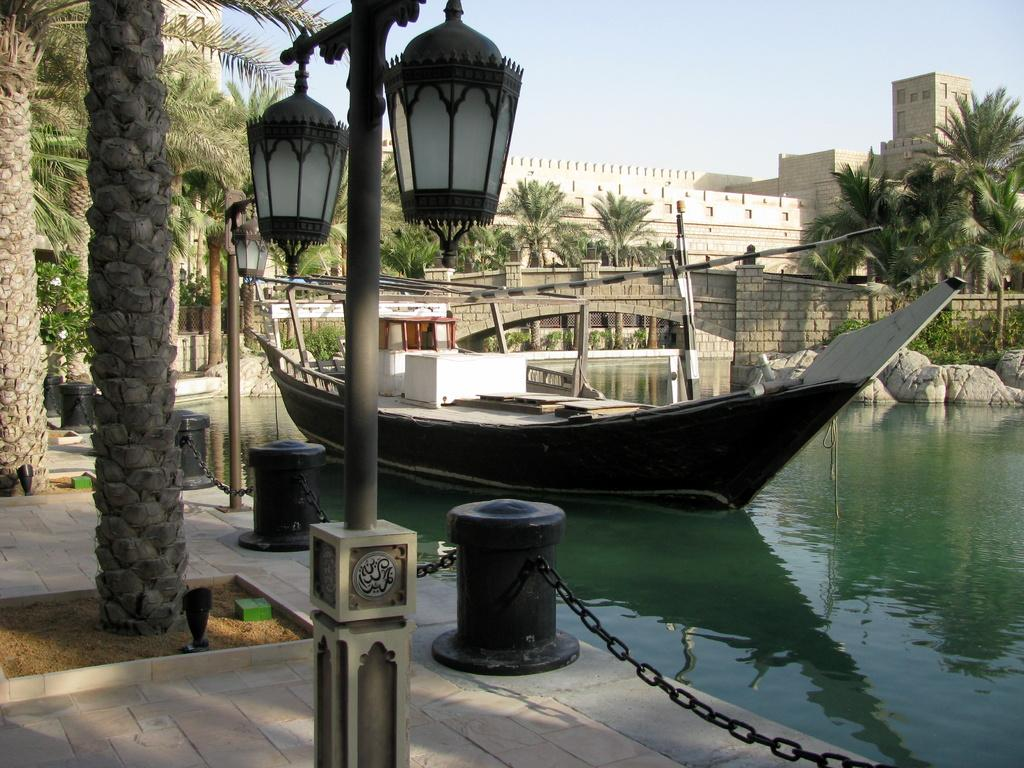What type of path can be seen in the image? There is a path in the image, but the specific type of path is not mentioned in the facts. What natural elements are present in the image? There are trees and water in the image. What man-made structures can be seen in the image? There are poles, lights, chains, a boat, rocks, a bridge, and a fort in the image. What is visible in the sky in the image? The sky is visible in the image, but the specific conditions or features of the sky are not mentioned in the facts. What type of fiction is being traded in the image? There is no mention of fiction or trade in the image. The image primarily features a path, trees, poles, lights, chains, water, a boat, rocks, a bridge, a fort, and the sky. 